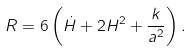Convert formula to latex. <formula><loc_0><loc_0><loc_500><loc_500>R = 6 \left ( \dot { H } + 2 H ^ { 2 } + \frac { k } { a ^ { 2 } } \right ) .</formula> 